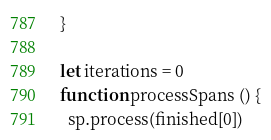Convert code to text. <code><loc_0><loc_0><loc_500><loc_500><_JavaScript_>}

let iterations = 0
function processSpans () {
  sp.process(finished[0])</code> 